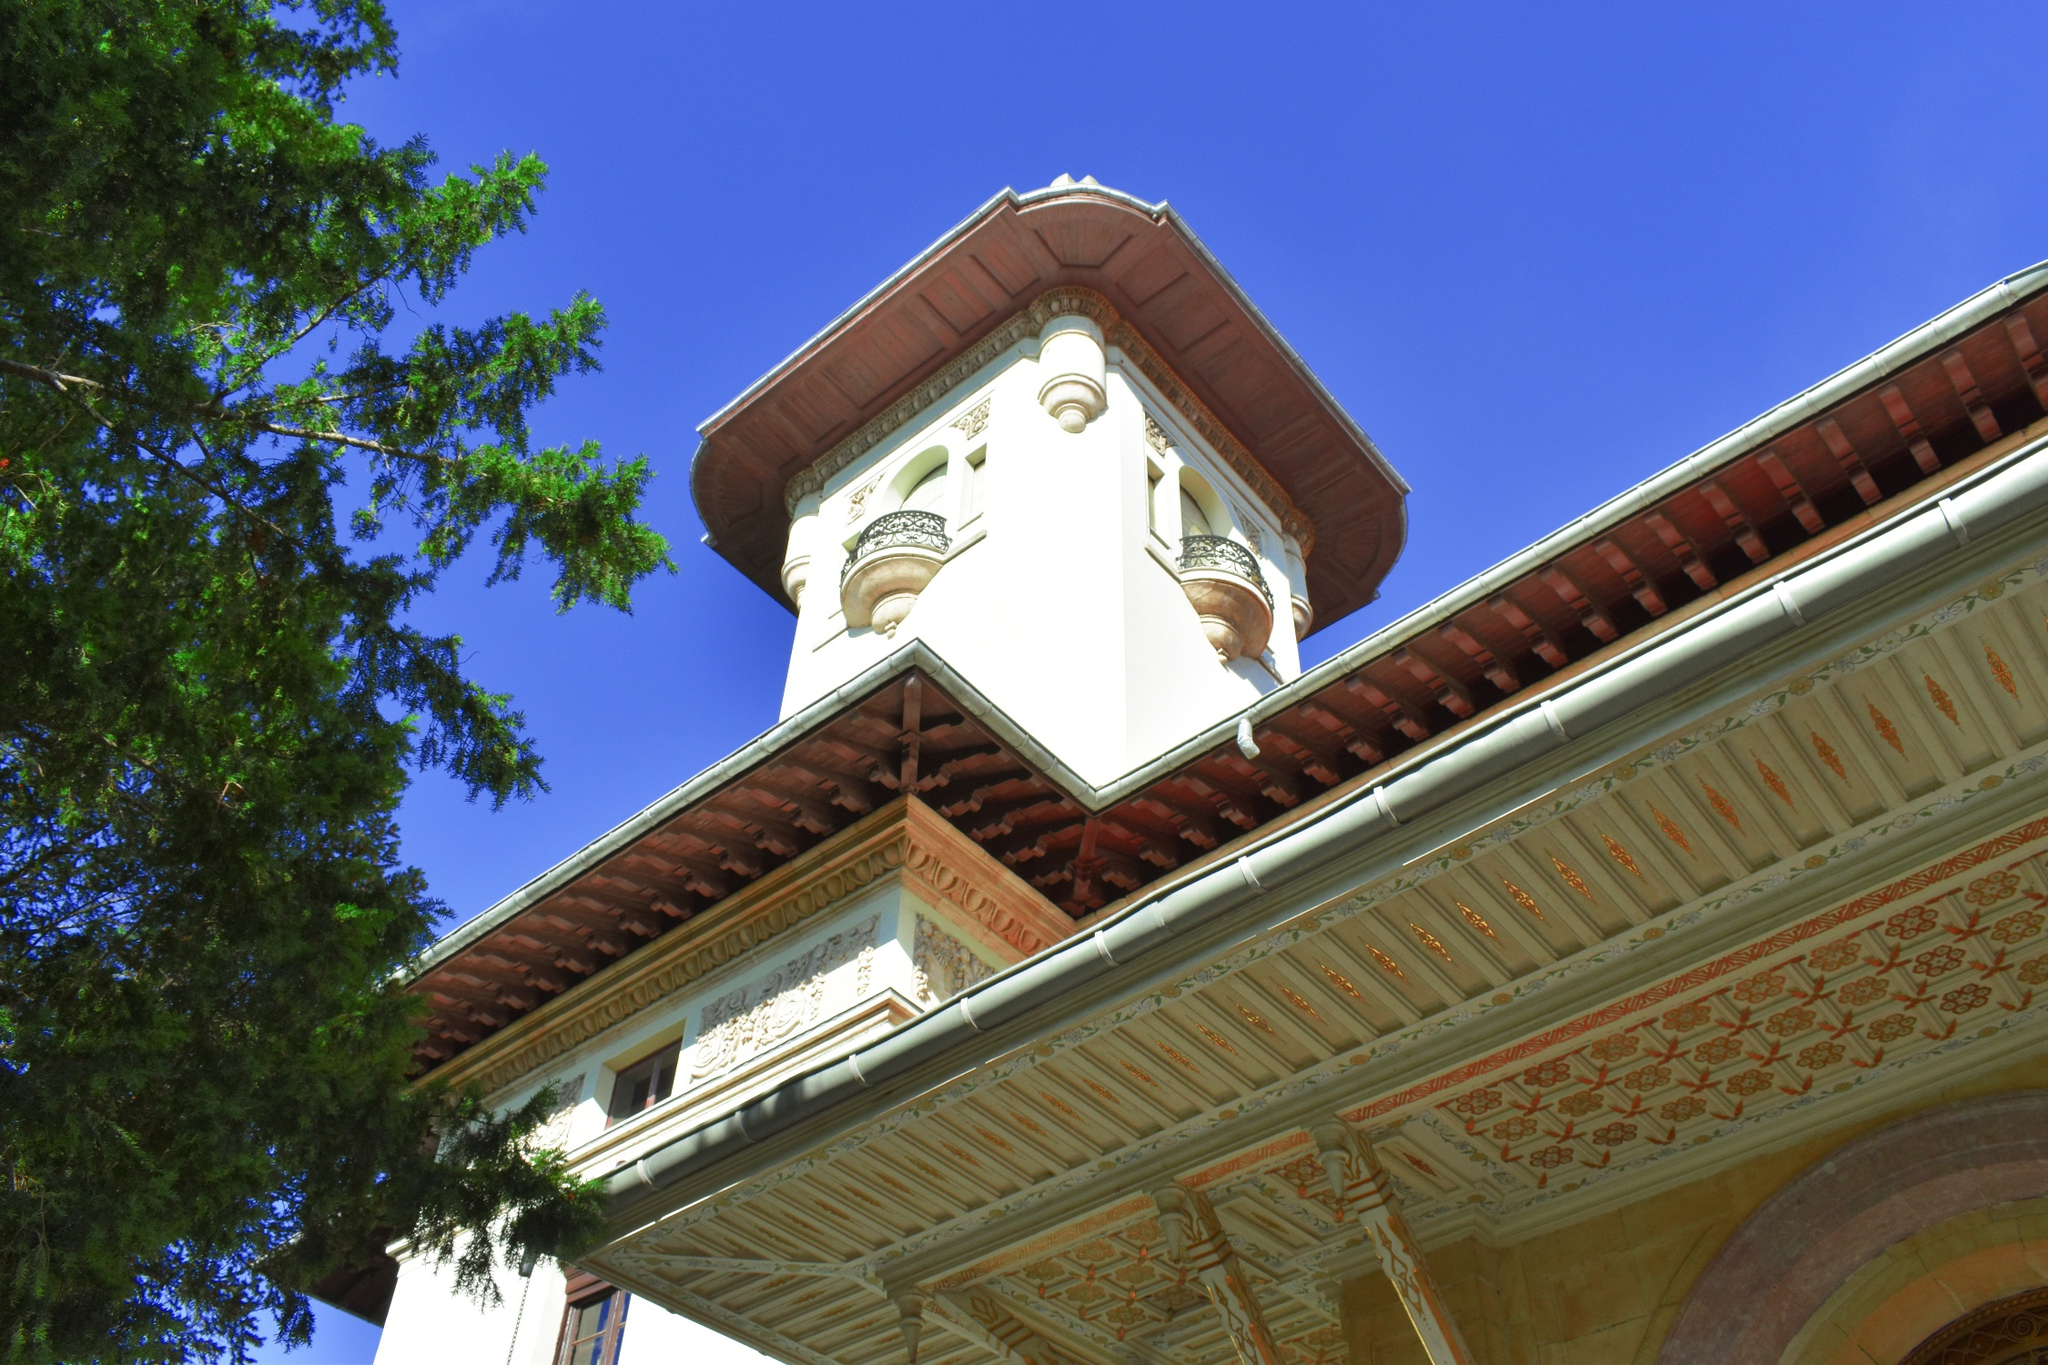Analyze the image in a comprehensive and detailed manner. The image captures a striking architectural piece that showcases an exquisite blend of design and detail. Dominating the scene is a tall white tower with a vibrant red roof, reaching towards a clear blue sky. The tower features three arched windows on each side, providing a glimpse into its intricate interior. At the top of the tower is a charming balcony, adding to the overall grandeur and appeal. The ornate patterns on the building's exterior enhance its aesthetic value, making it a spectacle to behold. The red roof provides a vivid contrast to the white walls, creating a visually pleasing color palette that draws the viewer's attention. The perspective of the image is taken from a low angle, emphasizing the towering presence of the structure and enhancing its imposing nature. The lush greenery of trees in the background complements the man-made structure, providing a natural frame that adds depth to the image. This architectural marvel, identified as 'sa_1126', stands as a testament to the brilliance and ingenuity of its design, evoking a sense of wonder and admiration. 